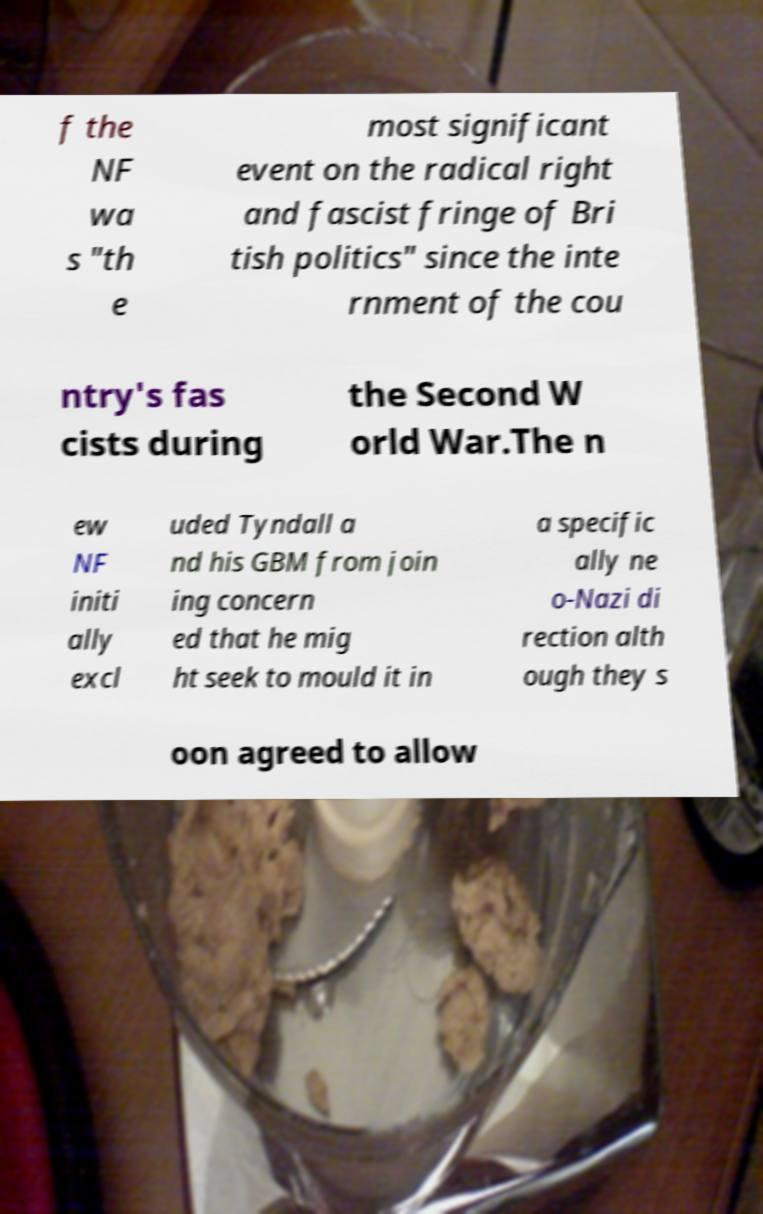There's text embedded in this image that I need extracted. Can you transcribe it verbatim? f the NF wa s "th e most significant event on the radical right and fascist fringe of Bri tish politics" since the inte rnment of the cou ntry's fas cists during the Second W orld War.The n ew NF initi ally excl uded Tyndall a nd his GBM from join ing concern ed that he mig ht seek to mould it in a specific ally ne o-Nazi di rection alth ough they s oon agreed to allow 